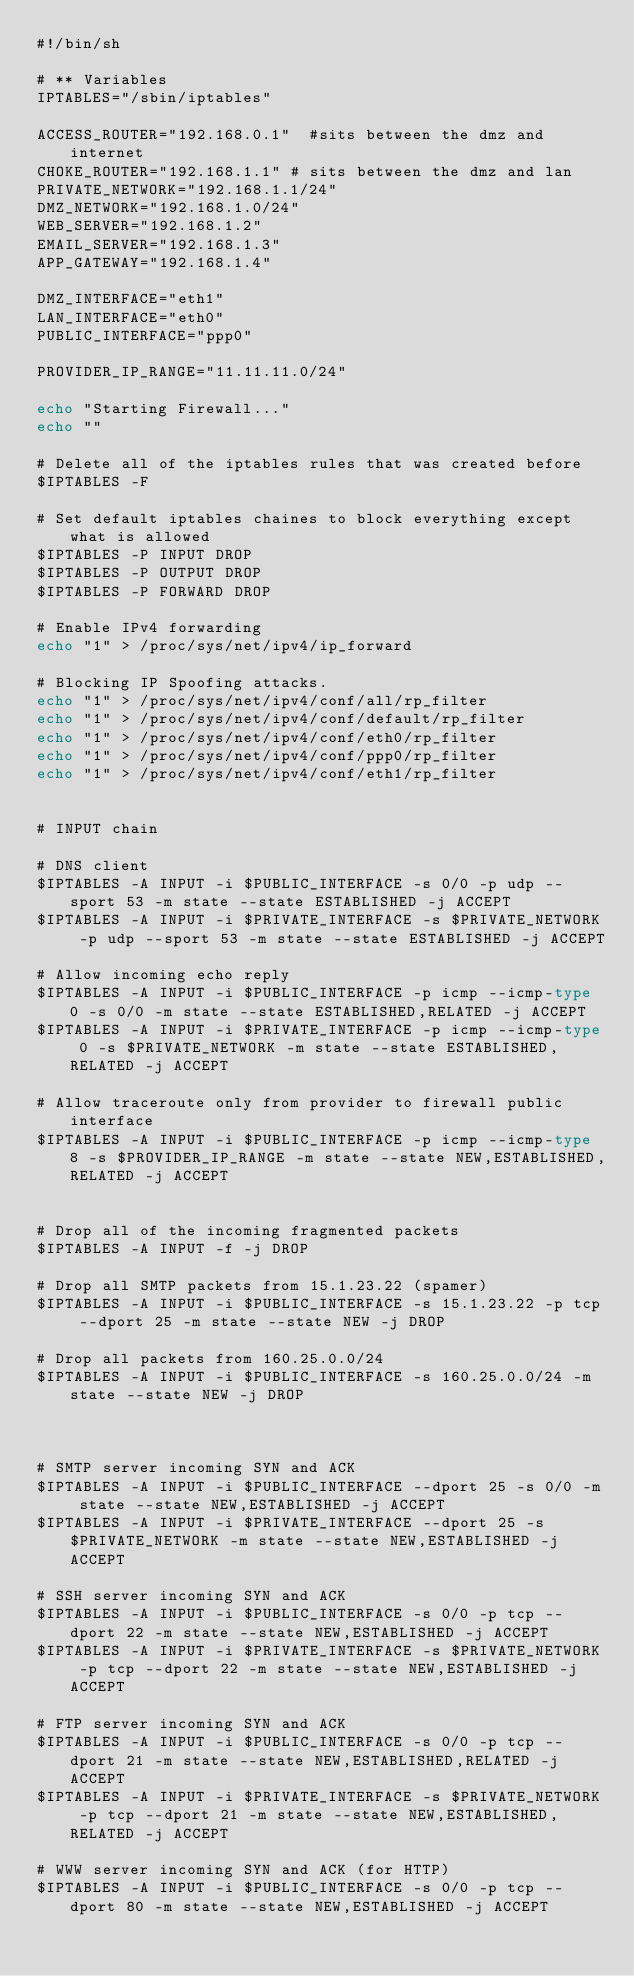<code> <loc_0><loc_0><loc_500><loc_500><_Bash_>#!/bin/sh

# ** Variables
IPTABLES="/sbin/iptables"

ACCESS_ROUTER="192.168.0.1"  #sits between the dmz and internet
CHOKE_ROUTER="192.168.1.1" # sits between the dmz and lan
PRIVATE_NETWORK="192.168.1.1/24"
DMZ_NETWORK="192.168.1.0/24"
WEB_SERVER="192.168.1.2"
EMAIL_SERVER="192.168.1.3"
APP_GATEWAY="192.168.1.4"

DMZ_INTERFACE="eth1"
LAN_INTERFACE="eth0"
PUBLIC_INTERFACE="ppp0"

PROVIDER_IP_RANGE="11.11.11.0/24"

echo "Starting Firewall..."
echo ""

# Delete all of the iptables rules that was created before
$IPTABLES -F

# Set default iptables chaines to block everything except what is allowed
$IPTABLES -P INPUT DROP
$IPTABLES -P OUTPUT DROP
$IPTABLES -P FORWARD DROP

# Enable IPv4 forwarding
echo "1" > /proc/sys/net/ipv4/ip_forward

# Blocking IP Spoofing attacks.
echo "1" > /proc/sys/net/ipv4/conf/all/rp_filter
echo "1" > /proc/sys/net/ipv4/conf/default/rp_filter
echo "1" > /proc/sys/net/ipv4/conf/eth0/rp_filter
echo "1" > /proc/sys/net/ipv4/conf/ppp0/rp_filter
echo "1" > /proc/sys/net/ipv4/conf/eth1/rp_filter


# INPUT chain

# DNS client
$IPTABLES -A INPUT -i $PUBLIC_INTERFACE -s 0/0 -p udp --sport 53 -m state --state ESTABLISHED -j ACCEPT
$IPTABLES -A INPUT -i $PRIVATE_INTERFACE -s $PRIVATE_NETWORK -p udp --sport 53 -m state --state ESTABLISHED -j ACCEPT

# Allow incoming echo reply
$IPTABLES -A INPUT -i $PUBLIC_INTERFACE -p icmp --icmp-type 0 -s 0/0 -m state --state ESTABLISHED,RELATED -j ACCEPT
$IPTABLES -A INPUT -i $PRIVATE_INTERFACE -p icmp --icmp-type 0 -s $PRIVATE_NETWORK -m state --state ESTABLISHED,RELATED -j ACCEPT

# Allow traceroute only from provider to firewall public interface
$IPTABLES -A INPUT -i $PUBLIC_INTERFACE -p icmp --icmp-type 8 -s $PROVIDER_IP_RANGE -m state --state NEW,ESTABLISHED,RELATED -j ACCEPT


# Drop all of the incoming fragmented packets
$IPTABLES -A INPUT -f -j DROP

# Drop all SMTP packets from 15.1.23.22 (spamer)
$IPTABLES -A INPUT -i $PUBLIC_INTERFACE -s 15.1.23.22 -p tcp --dport 25 -m state --state NEW -j DROP

# Drop all packets from 160.25.0.0/24
$IPTABLES -A INPUT -i $PUBLIC_INTERFACE -s 160.25.0.0/24 -m state --state NEW -j DROP



# SMTP server incoming SYN and ACK
$IPTABLES -A INPUT -i $PUBLIC_INTERFACE --dport 25 -s 0/0 -m state --state NEW,ESTABLISHED -j ACCEPT
$IPTABLES -A INPUT -i $PRIVATE_INTERFACE --dport 25 -s $PRIVATE_NETWORK -m state --state NEW,ESTABLISHED -j ACCEPT

# SSH server incoming SYN and ACK
$IPTABLES -A INPUT -i $PUBLIC_INTERFACE -s 0/0 -p tcp --dport 22 -m state --state NEW,ESTABLISHED -j ACCEPT
$IPTABLES -A INPUT -i $PRIVATE_INTERFACE -s $PRIVATE_NETWORK -p tcp --dport 22 -m state --state NEW,ESTABLISHED -j ACCEPT

# FTP server incoming SYN and ACK
$IPTABLES -A INPUT -i $PUBLIC_INTERFACE -s 0/0 -p tcp --dport 21 -m state --state NEW,ESTABLISHED,RELATED -j ACCEPT
$IPTABLES -A INPUT -i $PRIVATE_INTERFACE -s $PRIVATE_NETWORK -p tcp --dport 21 -m state --state NEW,ESTABLISHED,RELATED -j ACCEPT

# WWW server incoming SYN and ACK (for HTTP)
$IPTABLES -A INPUT -i $PUBLIC_INTERFACE -s 0/0 -p tcp --dport 80 -m state --state NEW,ESTABLISHED -j ACCEPT</code> 